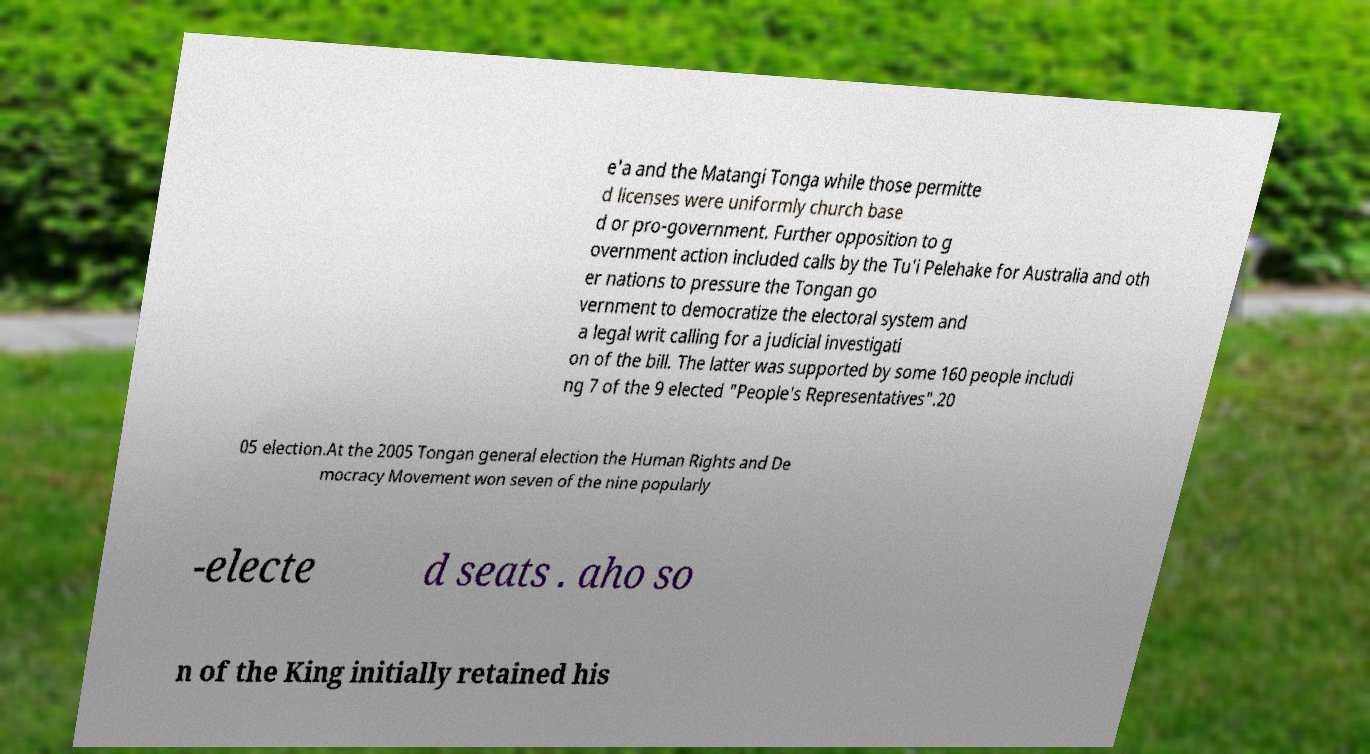What messages or text are displayed in this image? I need them in a readable, typed format. e'a and the Matangi Tonga while those permitte d licenses were uniformly church base d or pro-government. Further opposition to g overnment action included calls by the Tu'i Pelehake for Australia and oth er nations to pressure the Tongan go vernment to democratize the electoral system and a legal writ calling for a judicial investigati on of the bill. The latter was supported by some 160 people includi ng 7 of the 9 elected "People's Representatives".20 05 election.At the 2005 Tongan general election the Human Rights and De mocracy Movement won seven of the nine popularly -electe d seats . aho so n of the King initially retained his 